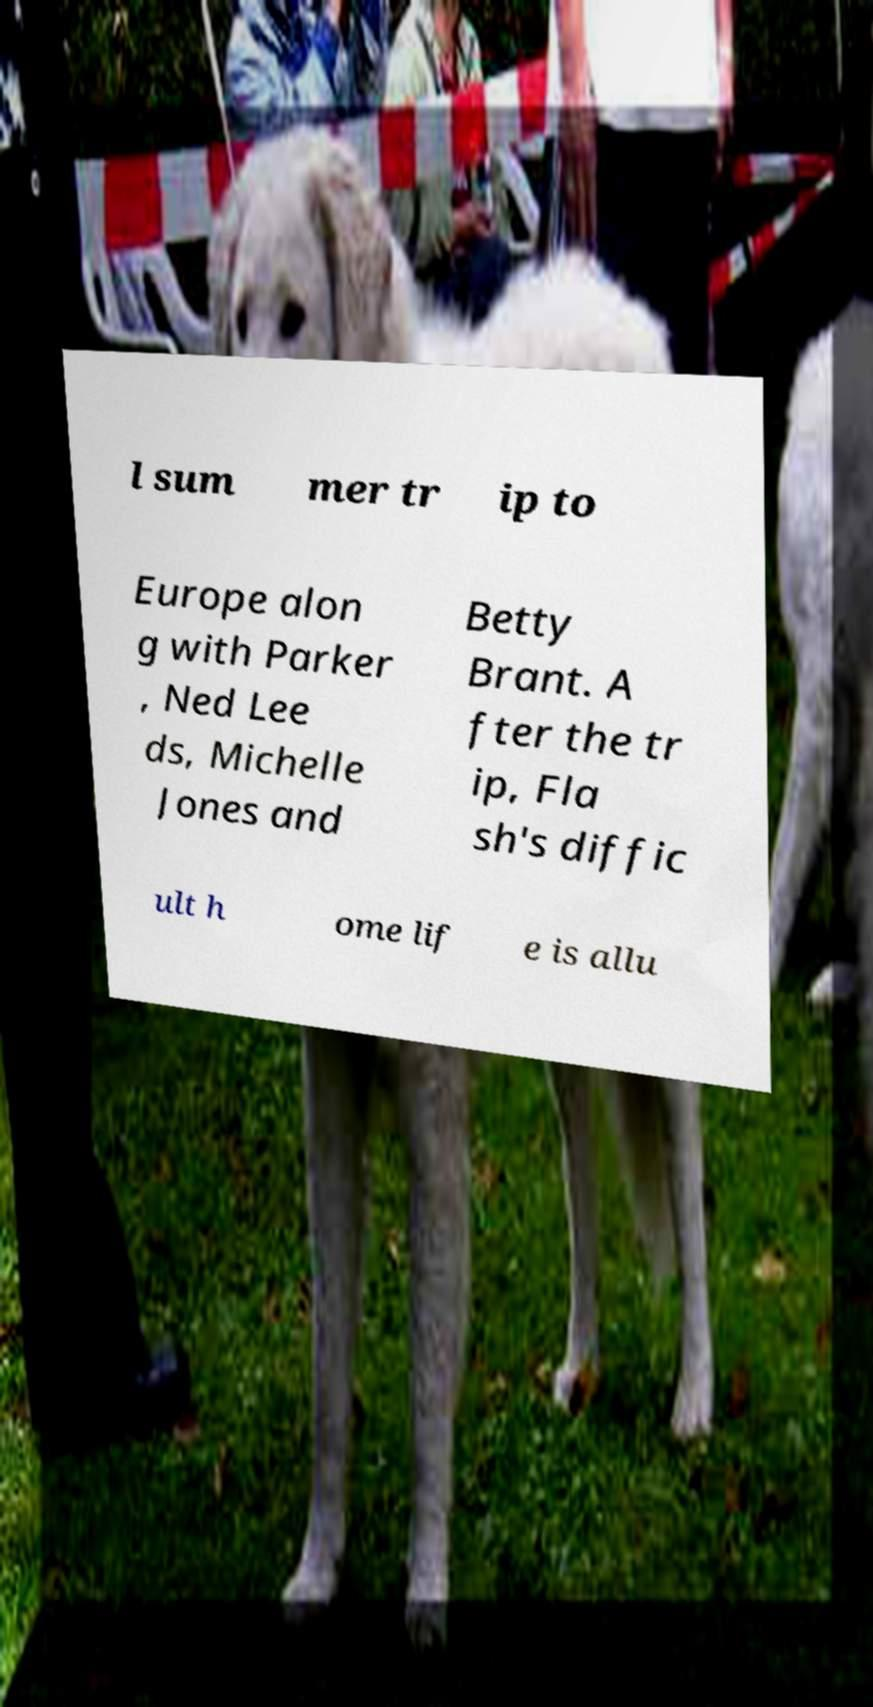Please read and relay the text visible in this image. What does it say? l sum mer tr ip to Europe alon g with Parker , Ned Lee ds, Michelle Jones and Betty Brant. A fter the tr ip, Fla sh's diffic ult h ome lif e is allu 